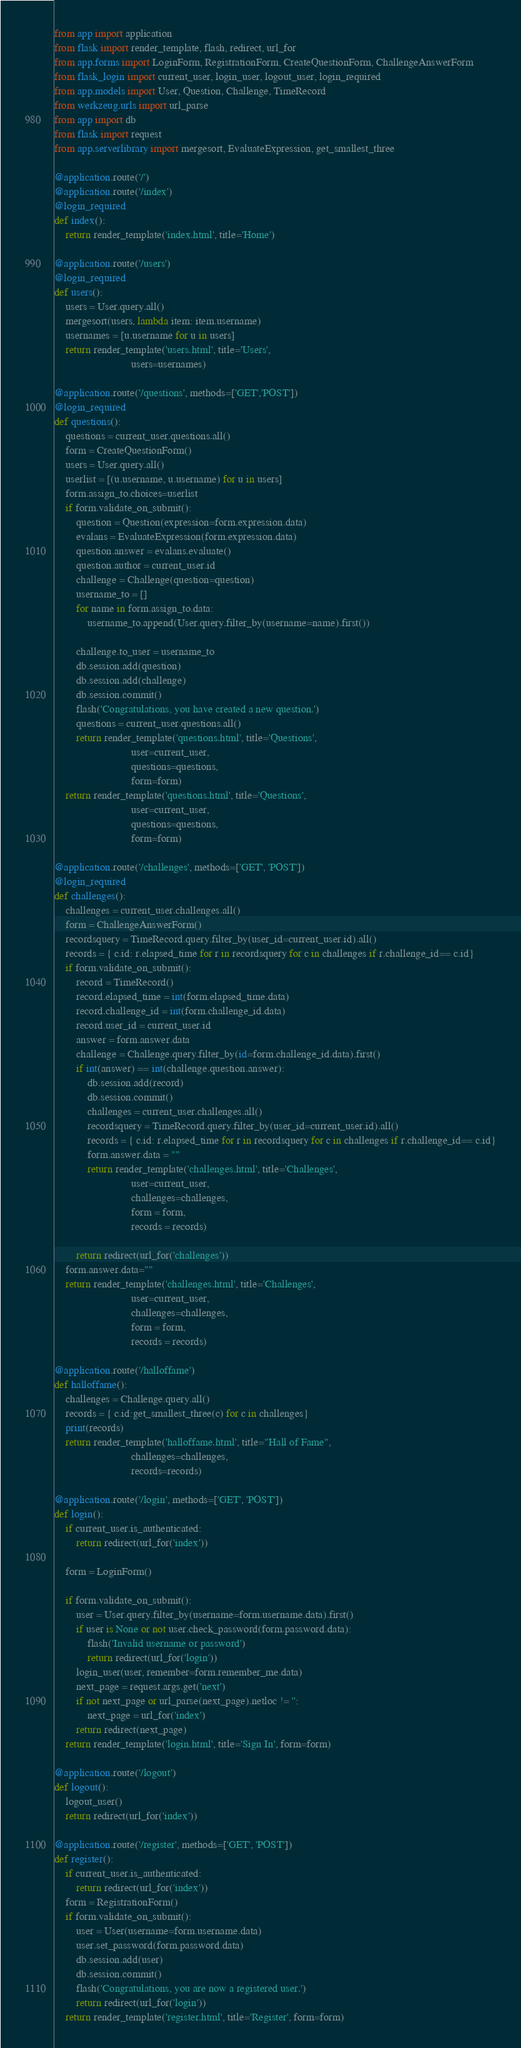Convert code to text. <code><loc_0><loc_0><loc_500><loc_500><_Python_>from app import application
from flask import render_template, flash, redirect, url_for
from app.forms import LoginForm, RegistrationForm, CreateQuestionForm, ChallengeAnswerForm
from flask_login import current_user, login_user, logout_user, login_required
from app.models import User, Question, Challenge, TimeRecord
from werkzeug.urls import url_parse
from app import db
from flask import request 
from app.serverlibrary import mergesort, EvaluateExpression, get_smallest_three 

@application.route('/')
@application.route('/index')
@login_required
def index():
	return render_template('index.html', title='Home')

@application.route('/users')
@login_required
def users():
	users = User.query.all()	
	mergesort(users, lambda item: item.username)
	usernames = [u.username for u in users]
	return render_template('users.html', title='Users',
							users=usernames)

@application.route('/questions', methods=['GET','POST'])
@login_required
def questions():
	questions = current_user.questions.all()
	form = CreateQuestionForm()
	users = User.query.all()
	userlist = [(u.username, u.username) for u in users]
	form.assign_to.choices=userlist
	if form.validate_on_submit():
		question = Question(expression=form.expression.data)
		evalans = EvaluateExpression(form.expression.data)
		question.answer = evalans.evaluate()
		question.author = current_user.id 
		challenge = Challenge(question=question)
		username_to = []
		for name in form.assign_to.data:
			username_to.append(User.query.filter_by(username=name).first())

		challenge.to_user = username_to
		db.session.add(question)
		db.session.add(challenge)
		db.session.commit()
		flash('Congratulations, you have created a new question.')
		questions = current_user.questions.all()
		return render_template('questions.html', title='Questions', 
							user=current_user,
							questions=questions,
							form=form)
	return render_template('questions.html', title='Questions', 
							user=current_user,
							questions=questions,
							form=form)

@application.route('/challenges', methods=['GET', 'POST'])
@login_required
def challenges():
	challenges = current_user.challenges.all()
	form = ChallengeAnswerForm()
	recordsquery = TimeRecord.query.filter_by(user_id=current_user.id).all()
	records = { c.id: r.elapsed_time for r in recordsquery for c in challenges if r.challenge_id== c.id}
	if form.validate_on_submit():
		record = TimeRecord()
		record.elapsed_time = int(form.elapsed_time.data)
		record.challenge_id = int(form.challenge_id.data)
		record.user_id = current_user.id
		answer = form.answer.data
		challenge = Challenge.query.filter_by(id=form.challenge_id.data).first()
		if int(answer) == int(challenge.question.answer):
			db.session.add(record)
			db.session.commit()
			challenges = current_user.challenges.all()
			recordsquery = TimeRecord.query.filter_by(user_id=current_user.id).all()
			records = { c.id: r.elapsed_time for r in recordsquery for c in challenges if r.challenge_id== c.id}
			form.answer.data = ""
			return render_template('challenges.html', title='Challenges',
							user=current_user,
							challenges=challenges,
							form = form,
							records = records)
		
		return redirect(url_for('challenges'))
	form.answer.data=""
	return render_template('challenges.html', title='Challenges',
							user=current_user,
							challenges=challenges,
							form = form,
							records = records)

@application.route('/halloffame')
def halloffame():
	challenges = Challenge.query.all()
	records = { c.id:get_smallest_three(c) for c in challenges}
	print(records)
	return render_template('halloffame.html', title="Hall of Fame",
							challenges=challenges,
							records=records)

@application.route('/login', methods=['GET', 'POST'])
def login():
	if current_user.is_authenticated:
		return redirect(url_for('index'))

	form = LoginForm()

	if form.validate_on_submit():
		user = User.query.filter_by(username=form.username.data).first()
		if user is None or not user.check_password(form.password.data):
			flash('Invalid username or password')
			return redirect(url_for('login'))
		login_user(user, remember=form.remember_me.data)
		next_page = request.args.get('next')
		if not next_page or url_parse(next_page).netloc != '':
			next_page = url_for('index')
		return redirect(next_page)
	return render_template('login.html', title='Sign In', form=form)

@application.route('/logout')
def logout():
	logout_user()
	return redirect(url_for('index'))

@application.route('/register', methods=['GET', 'POST'])
def register():
	if current_user.is_authenticated:
		return redirect(url_for('index'))
	form = RegistrationForm()
	if form.validate_on_submit():
		user = User(username=form.username.data)
		user.set_password(form.password.data)
		db.session.add(user)
		db.session.commit()
		flash('Congratulations, you are now a registered user.')
		return redirect(url_for('login'))
	return render_template('register.html', title='Register', form=form)

</code> 